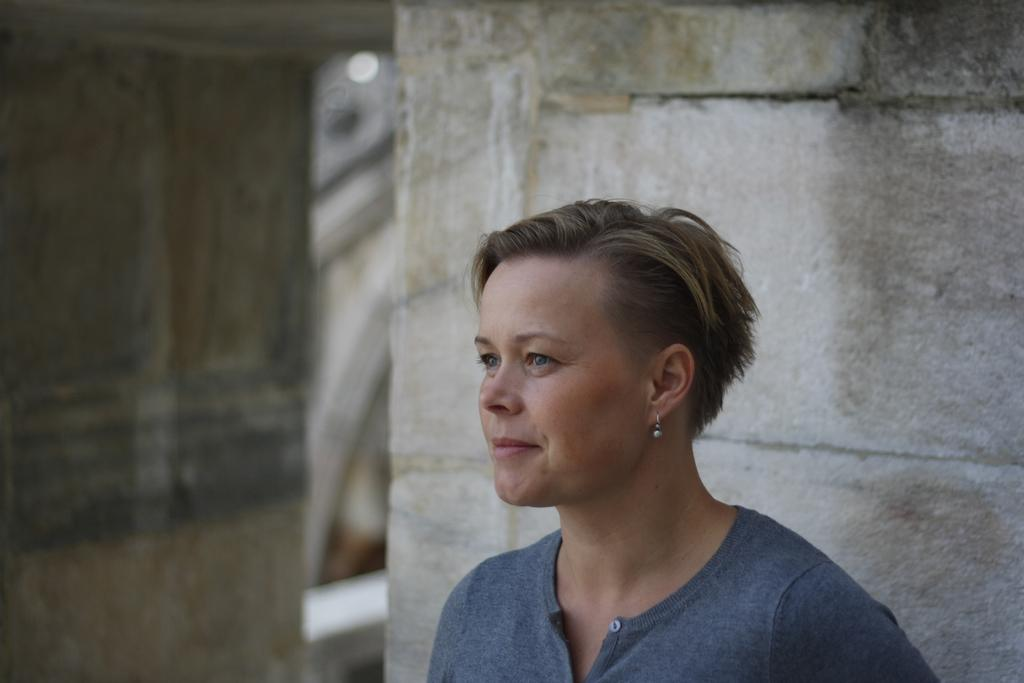What is the main subject of the image? There is a person in the image. What is the person wearing? The person is wearing a blue t-shirt. What is the person doing in the image? The person is standing and smiling. What can be seen in the background of the image? There is a building in the background of the image. How many pets are visible in the image? There are no pets present in the image. What type of twist is the person performing in the image? The person is not performing any twist in the image; they are simply standing and smiling. 